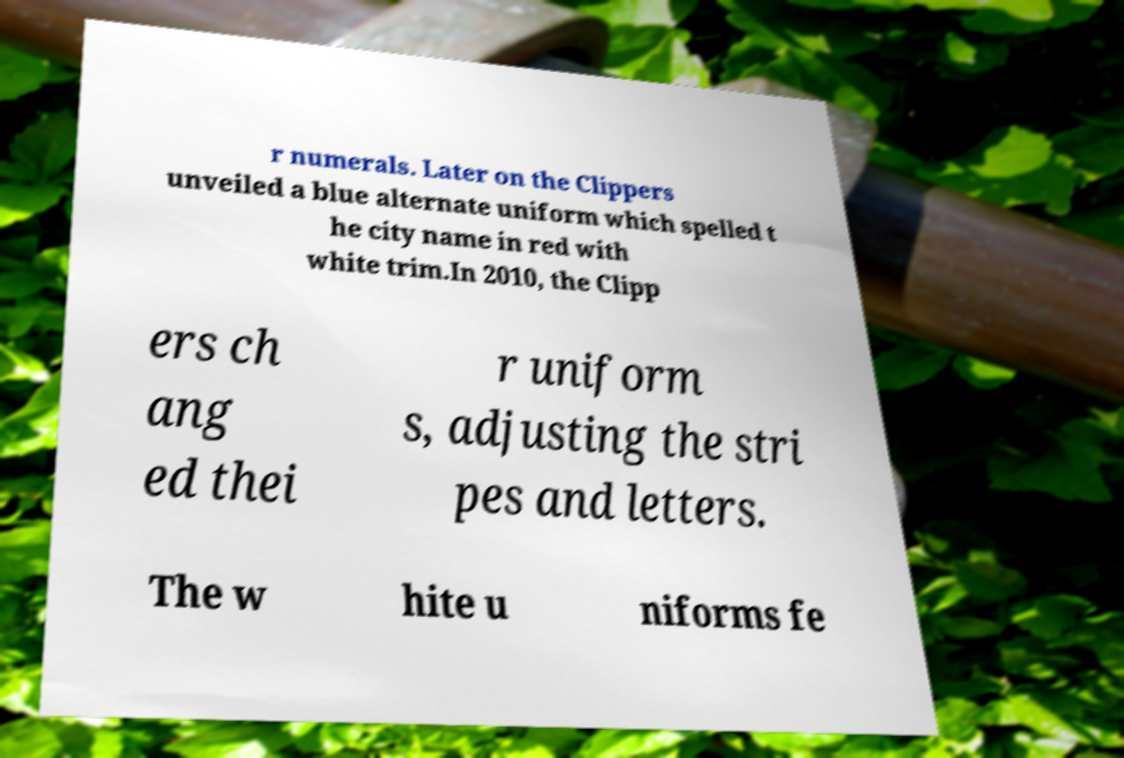There's text embedded in this image that I need extracted. Can you transcribe it verbatim? r numerals. Later on the Clippers unveiled a blue alternate uniform which spelled t he city name in red with white trim.In 2010, the Clipp ers ch ang ed thei r uniform s, adjusting the stri pes and letters. The w hite u niforms fe 